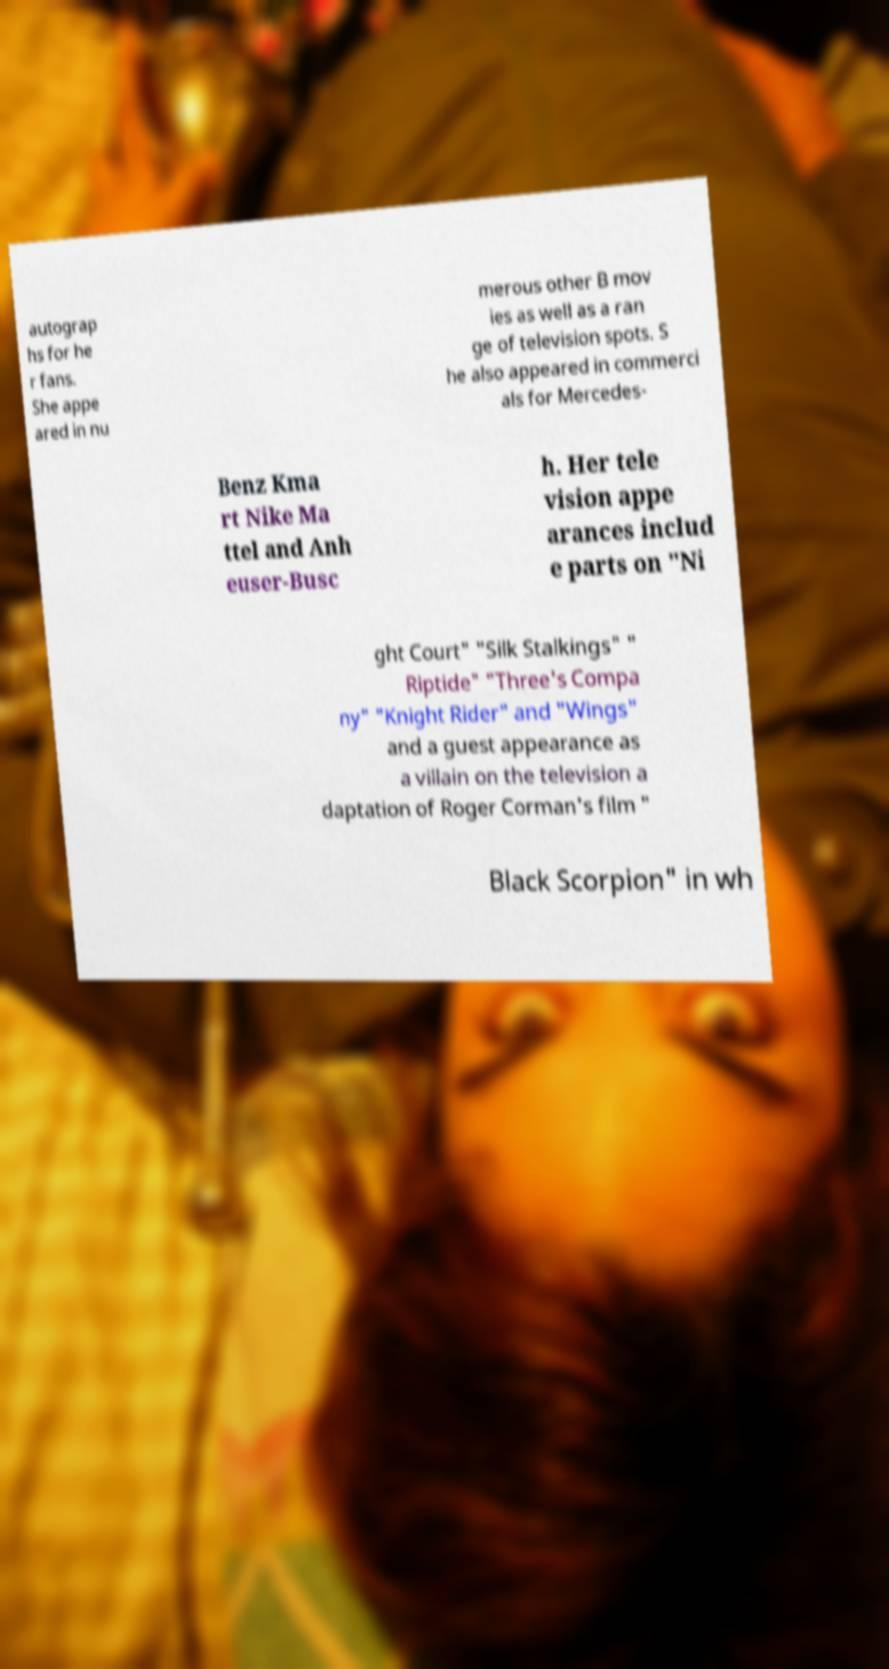For documentation purposes, I need the text within this image transcribed. Could you provide that? autograp hs for he r fans. She appe ared in nu merous other B mov ies as well as a ran ge of television spots. S he also appeared in commerci als for Mercedes- Benz Kma rt Nike Ma ttel and Anh euser-Busc h. Her tele vision appe arances includ e parts on "Ni ght Court" "Silk Stalkings" " Riptide" "Three's Compa ny" "Knight Rider" and "Wings" and a guest appearance as a villain on the television a daptation of Roger Corman's film " Black Scorpion" in wh 